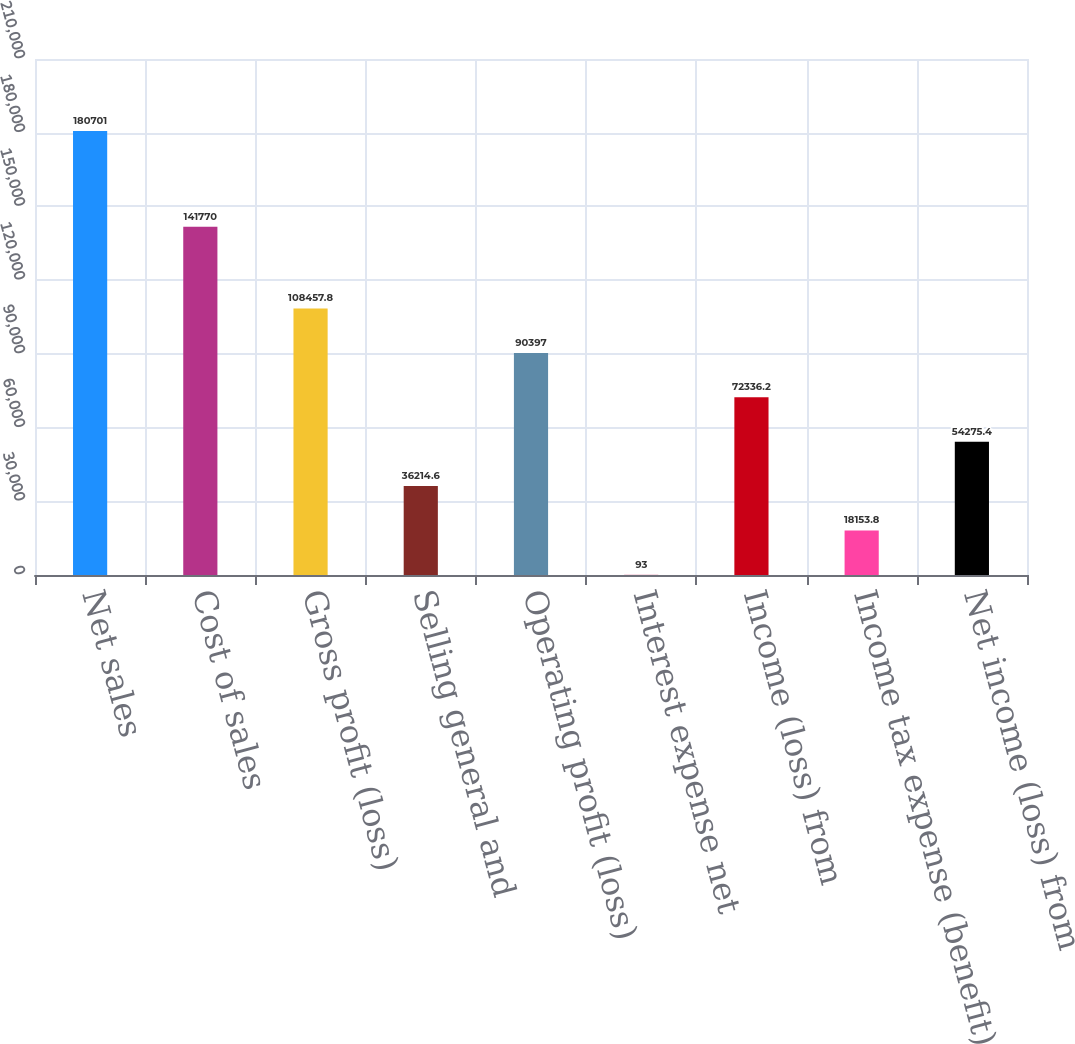Convert chart. <chart><loc_0><loc_0><loc_500><loc_500><bar_chart><fcel>Net sales<fcel>Cost of sales<fcel>Gross profit (loss)<fcel>Selling general and<fcel>Operating profit (loss)<fcel>Interest expense net<fcel>Income (loss) from<fcel>Income tax expense (benefit)<fcel>Net income (loss) from<nl><fcel>180701<fcel>141770<fcel>108458<fcel>36214.6<fcel>90397<fcel>93<fcel>72336.2<fcel>18153.8<fcel>54275.4<nl></chart> 